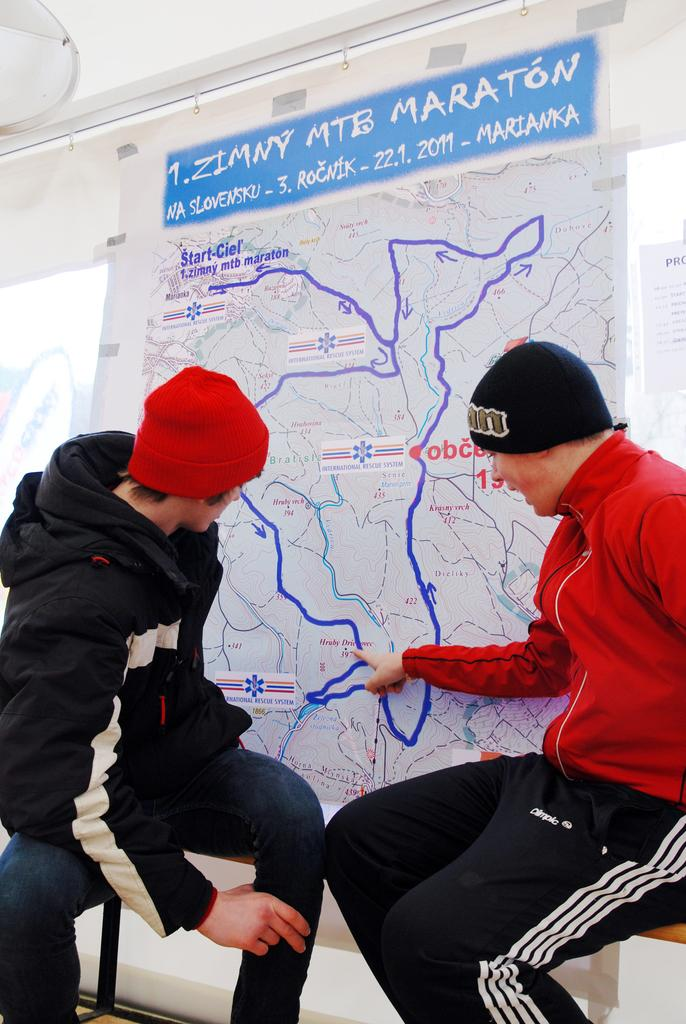How many people are in the image? There are two boys in the image. What are the boys wearing? The boys are wearing black and red color hoodies. What are the boys doing in the image? The boys are sitting on a bench. What are the boys looking at? The boys are looking at a map banner. What can be seen in the background of the image? There is a glass wall in the background of the image. What type of crime is being committed by the boys in the image? There is no indication of any crime being committed in the image; the boys are simply sitting on a bench and looking at a map banner. 